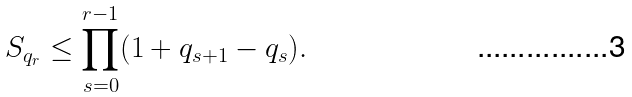<formula> <loc_0><loc_0><loc_500><loc_500>S _ { q _ { r } } \leq \prod _ { s = 0 } ^ { r - 1 } ( 1 + q _ { s + 1 } - q _ { s } ) .</formula> 